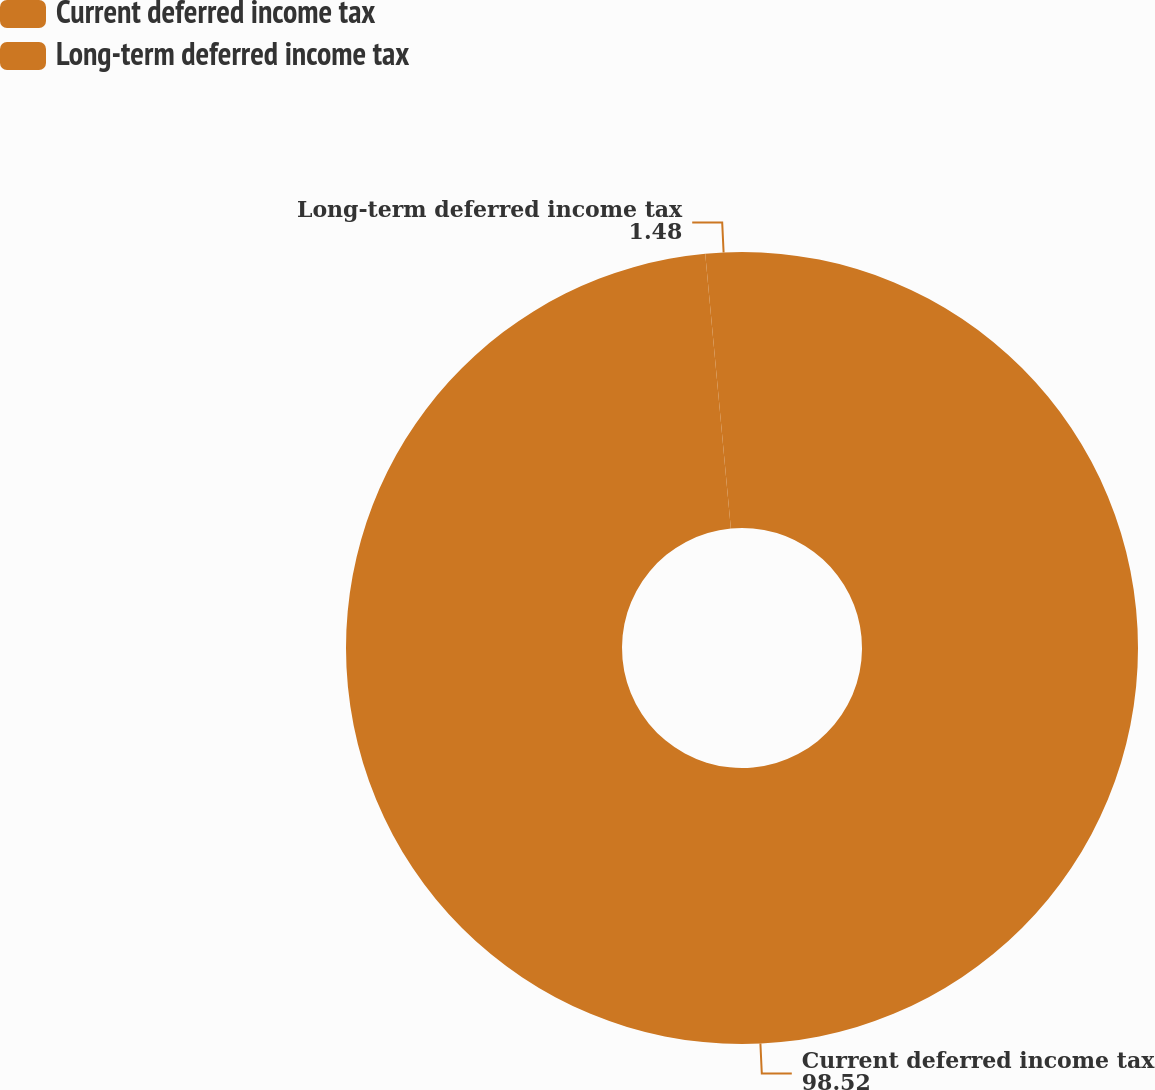Convert chart. <chart><loc_0><loc_0><loc_500><loc_500><pie_chart><fcel>Current deferred income tax<fcel>Long-term deferred income tax<nl><fcel>98.52%<fcel>1.48%<nl></chart> 